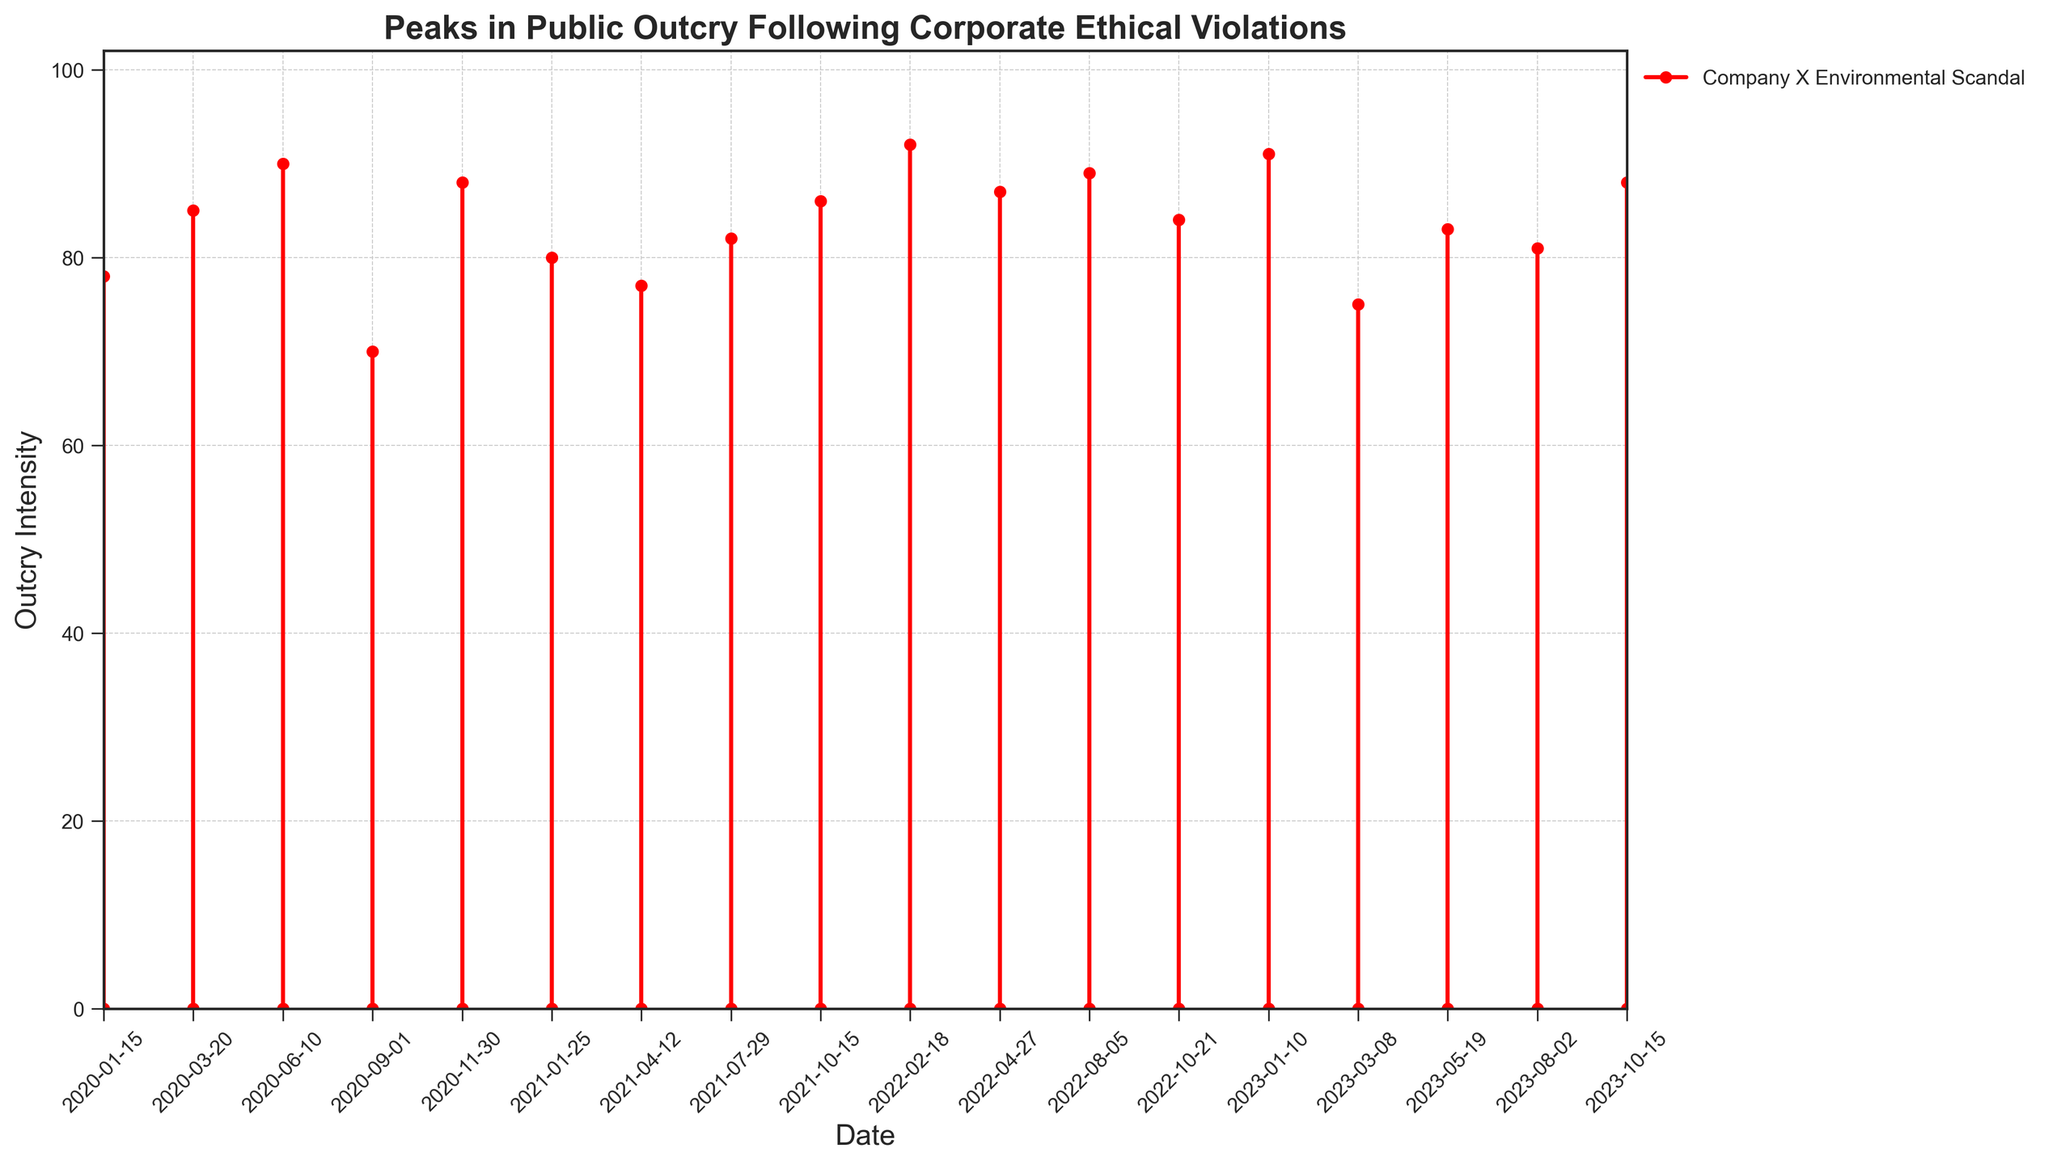What is the highest peak in public outcry intensity and which event does it correspond to? To find the highest peak, examine the top point on the 'Outcry Intensity' axis and identify the corresponding event. The tallest line goes up to 92, corresponding to the 'Company G CEO Misconduct Allegations' event.
Answer: Company's G CEO Misconduct Allegations Which event had the lowest outcry intensity and what was its value? Identify the shortest line on the plot. The shortest line goes up to 70, which corresponds to the 'Company A Tax Evasion Revelations' event.
Answer: Company A Tax Evasion Revelations, 70 How many events exceeded an outcry intensity of 85? Count the number of lines that peak above the 85 mark on the outcry intensity axis. The events exceeding an intensity of 85 are Company Y, Company Z, Company B, Company F, Company G, Company I, Company K, and Company O. This makes a total of eight events.
Answer: 8 What is the difference in public outcry intensity between the 'Company X Environmental Scandal' and the 'Company D Political Contribution Controversy'? Find the outcry intensity values for both events and compute their difference. The intensity for 'Company X Environmental Scandal' is 78 and for 'Company D Political Contribution Controversy' is 77. Thus, the difference is 78 - 77 = 1.
Answer: 1 Which two consecutive events had the largest increase in public outcry intensity? Compare the differences in intensity values between every pair of consecutive events. The largest increase is observed between 'Company F Environmental Violation' (86) and 'Company G CEO Misconduct Allegations' (92). The difference is 92 - 86 = 6.
Answer: Company F Environmental Violation to Company G CEO Misconduct Allegations 